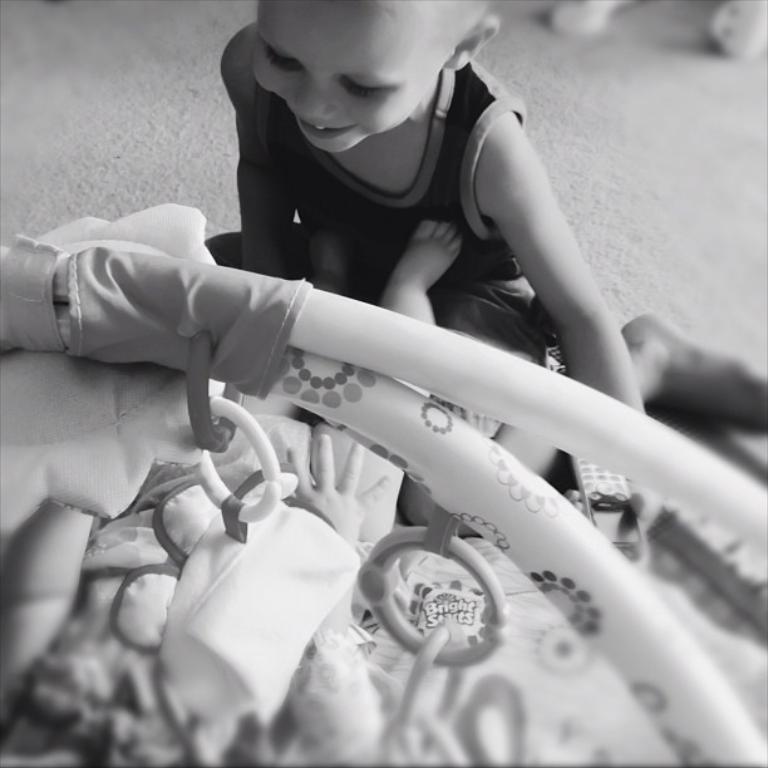In one or two sentences, can you explain what this image depicts? In this image there is a child sitting in front of the cradle, on which there is a baby. 